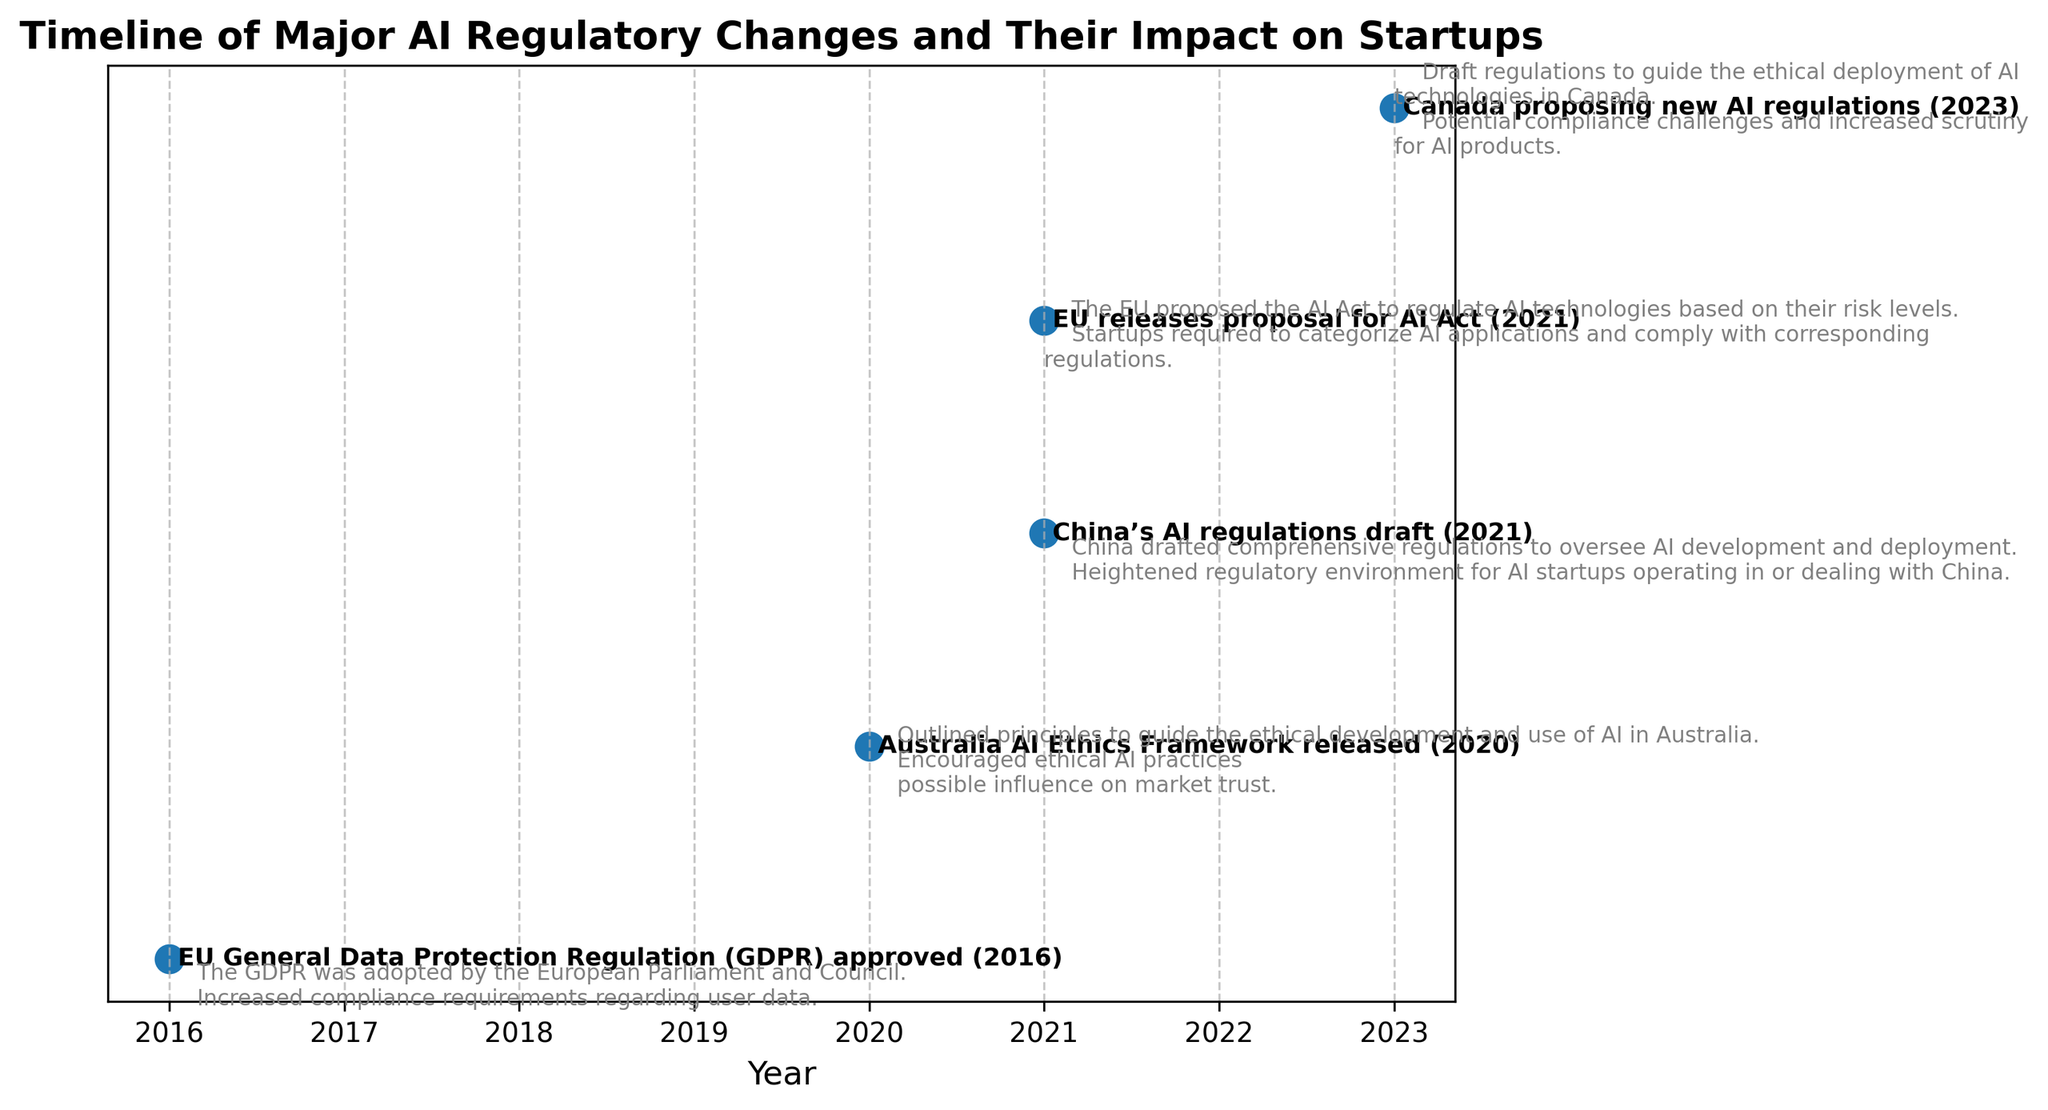When was the EU General Data Protection Regulation (GDPR) approved, and what was its impact on startups? The EU General Data Protection Regulation (GDPR) was approved in 2016. Its impact on startups included increased compliance requirements regarding user data.
Answer: 2016, Increased compliance requirements regarding user data Which regulatory change encouraged ethical AI practices and potentially influenced market trust? The Australia AI Ethics Framework released in 2020 encouraged ethical AI practices and potentially influenced market trust.
Answer: Australia AI Ethics Framework, 2020 Between the years 2021 and 2023, how many major regulatory changes are presented in the figure, and what are their cumulative impacts on startups? There are three major regulatory changes presented between 2021 and 2023: 
1) China’s AI regulations draft (2021) which heightened regulatory environment for AI startups operating in or dealing with China.
2) EU's proposal for the AI Act (2021) which required startups to categorize AI applications and comply with corresponding regulations.
3) Canada's draft AI regulations (2023) which posed potential compliance challenges and increased scrutiny for AI products.
Answer: Three; heightened regulatory environment, categorization and compliance requirements, and increased scrutiny Which event in the figure required startups to categorize AI applications based on risk levels, and in which year did this occur? The EU's proposal for the AI Act required startups to categorize AI applications based on risk levels. This occurred in 2021.
Answer: EU proposal for AI Act, 2021 Compare the impact on startups between the Australia AI Ethics Framework and China’s AI regulations draft. Which had a more direct regulatory imposition? The Australia AI Ethics Framework encouraged ethical AI practices and possibly influenced market trust, while China's AI regulations draft heightened the regulatory environment. The latter had a more direct regulatory imposition on startups.
Answer: China's AI regulations draft Which regulatory event had the earliest year mentioned in the plot? The EU General Data Protection Regulation (GDPR) approved in 2016 had the earliest year mentioned in the plot.
Answer: GDPR, 2016 